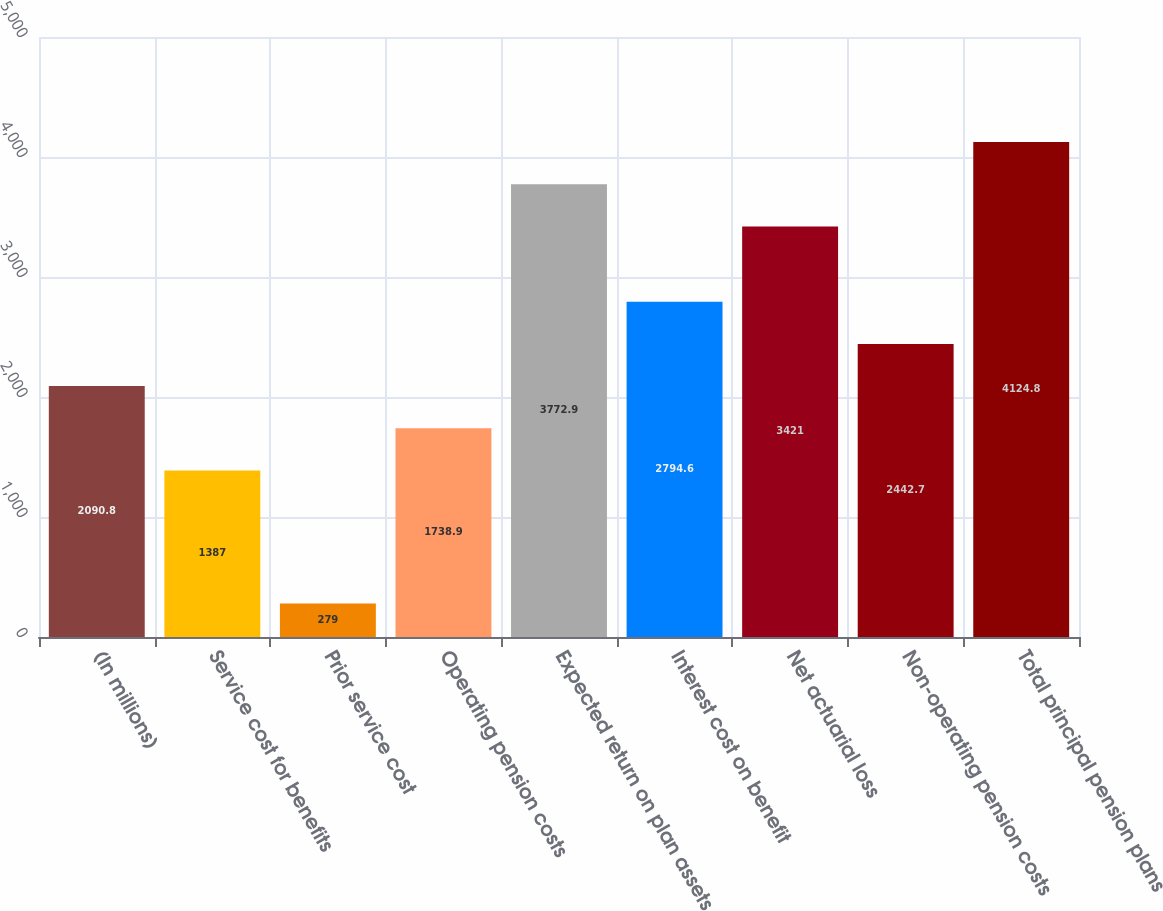Convert chart to OTSL. <chart><loc_0><loc_0><loc_500><loc_500><bar_chart><fcel>(In millions)<fcel>Service cost for benefits<fcel>Prior service cost<fcel>Operating pension costs<fcel>Expected return on plan assets<fcel>Interest cost on benefit<fcel>Net actuarial loss<fcel>Non-operating pension costs<fcel>Total principal pension plans<nl><fcel>2090.8<fcel>1387<fcel>279<fcel>1738.9<fcel>3772.9<fcel>2794.6<fcel>3421<fcel>2442.7<fcel>4124.8<nl></chart> 